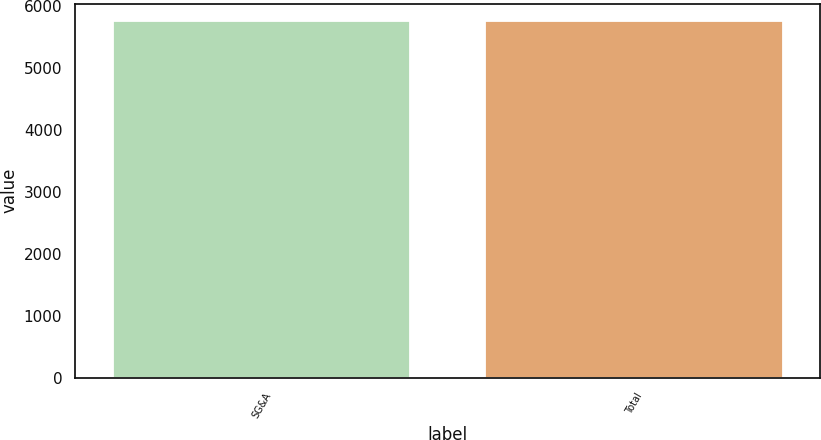Convert chart to OTSL. <chart><loc_0><loc_0><loc_500><loc_500><bar_chart><fcel>SG&A<fcel>Total<nl><fcel>5751<fcel>5751.1<nl></chart> 